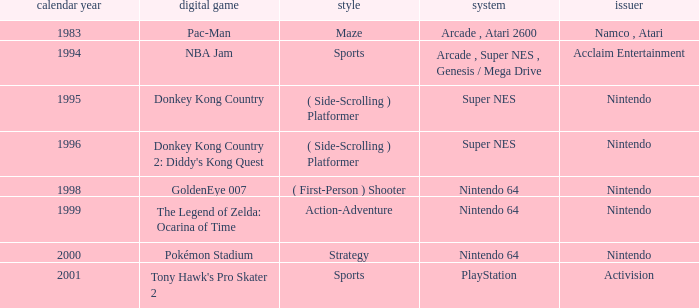Which Genre has a Year larger than 1999, and a Game of tony hawk's pro skater 2? Sports. 